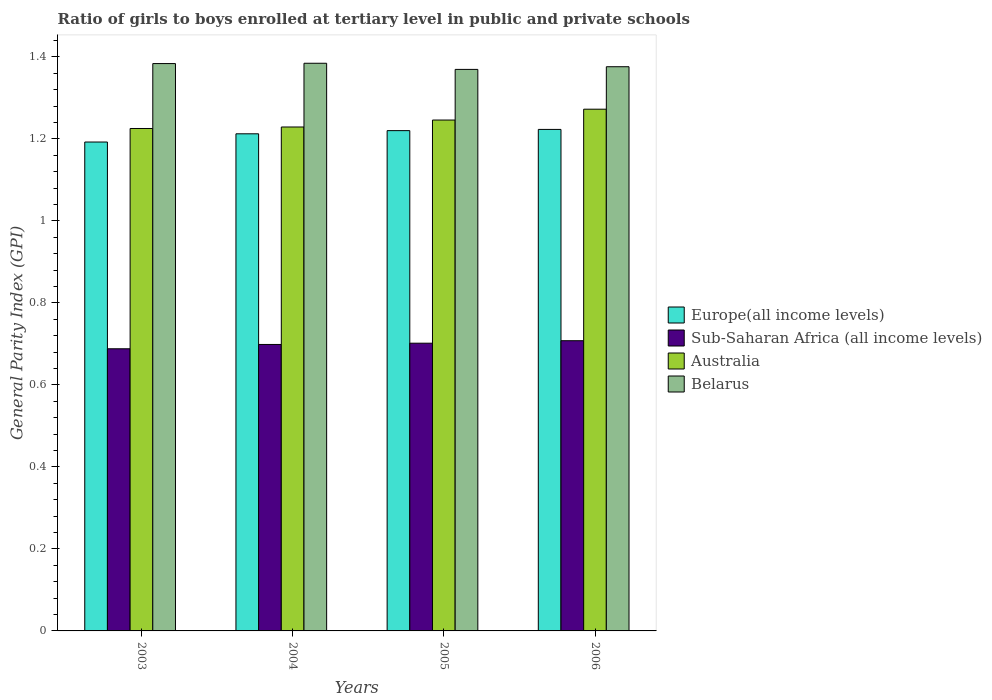Are the number of bars per tick equal to the number of legend labels?
Your answer should be very brief. Yes. How many bars are there on the 4th tick from the right?
Provide a succinct answer. 4. What is the label of the 1st group of bars from the left?
Offer a very short reply. 2003. What is the general parity index in Europe(all income levels) in 2003?
Ensure brevity in your answer.  1.19. Across all years, what is the maximum general parity index in Sub-Saharan Africa (all income levels)?
Keep it short and to the point. 0.71. Across all years, what is the minimum general parity index in Europe(all income levels)?
Your answer should be very brief. 1.19. In which year was the general parity index in Europe(all income levels) maximum?
Give a very brief answer. 2006. In which year was the general parity index in Sub-Saharan Africa (all income levels) minimum?
Your response must be concise. 2003. What is the total general parity index in Belarus in the graph?
Your answer should be compact. 5.51. What is the difference between the general parity index in Sub-Saharan Africa (all income levels) in 2004 and that in 2006?
Keep it short and to the point. -0.01. What is the difference between the general parity index in Europe(all income levels) in 2005 and the general parity index in Sub-Saharan Africa (all income levels) in 2006?
Offer a terse response. 0.51. What is the average general parity index in Belarus per year?
Provide a succinct answer. 1.38. In the year 2004, what is the difference between the general parity index in Australia and general parity index in Sub-Saharan Africa (all income levels)?
Offer a very short reply. 0.53. In how many years, is the general parity index in Belarus greater than 0.16?
Make the answer very short. 4. What is the ratio of the general parity index in Australia in 2004 to that in 2006?
Keep it short and to the point. 0.97. Is the difference between the general parity index in Australia in 2003 and 2004 greater than the difference between the general parity index in Sub-Saharan Africa (all income levels) in 2003 and 2004?
Ensure brevity in your answer.  Yes. What is the difference between the highest and the second highest general parity index in Belarus?
Your response must be concise. 0. What is the difference between the highest and the lowest general parity index in Sub-Saharan Africa (all income levels)?
Offer a terse response. 0.02. In how many years, is the general parity index in Australia greater than the average general parity index in Australia taken over all years?
Offer a terse response. 2. Is the sum of the general parity index in Europe(all income levels) in 2003 and 2006 greater than the maximum general parity index in Belarus across all years?
Ensure brevity in your answer.  Yes. Is it the case that in every year, the sum of the general parity index in Sub-Saharan Africa (all income levels) and general parity index in Australia is greater than the sum of general parity index in Belarus and general parity index in Europe(all income levels)?
Your answer should be compact. Yes. What does the 2nd bar from the left in 2005 represents?
Offer a terse response. Sub-Saharan Africa (all income levels). What does the 3rd bar from the right in 2006 represents?
Provide a short and direct response. Sub-Saharan Africa (all income levels). How many years are there in the graph?
Your answer should be very brief. 4. What is the difference between two consecutive major ticks on the Y-axis?
Your answer should be very brief. 0.2. Are the values on the major ticks of Y-axis written in scientific E-notation?
Give a very brief answer. No. Does the graph contain any zero values?
Keep it short and to the point. No. Where does the legend appear in the graph?
Your response must be concise. Center right. What is the title of the graph?
Provide a succinct answer. Ratio of girls to boys enrolled at tertiary level in public and private schools. What is the label or title of the X-axis?
Your answer should be very brief. Years. What is the label or title of the Y-axis?
Keep it short and to the point. General Parity Index (GPI). What is the General Parity Index (GPI) in Europe(all income levels) in 2003?
Make the answer very short. 1.19. What is the General Parity Index (GPI) in Sub-Saharan Africa (all income levels) in 2003?
Your response must be concise. 0.69. What is the General Parity Index (GPI) in Australia in 2003?
Offer a terse response. 1.23. What is the General Parity Index (GPI) of Belarus in 2003?
Your answer should be very brief. 1.38. What is the General Parity Index (GPI) of Europe(all income levels) in 2004?
Ensure brevity in your answer.  1.21. What is the General Parity Index (GPI) in Sub-Saharan Africa (all income levels) in 2004?
Make the answer very short. 0.7. What is the General Parity Index (GPI) of Australia in 2004?
Provide a succinct answer. 1.23. What is the General Parity Index (GPI) of Belarus in 2004?
Your answer should be very brief. 1.38. What is the General Parity Index (GPI) in Europe(all income levels) in 2005?
Offer a very short reply. 1.22. What is the General Parity Index (GPI) in Sub-Saharan Africa (all income levels) in 2005?
Give a very brief answer. 0.7. What is the General Parity Index (GPI) in Australia in 2005?
Keep it short and to the point. 1.25. What is the General Parity Index (GPI) in Belarus in 2005?
Offer a very short reply. 1.37. What is the General Parity Index (GPI) in Europe(all income levels) in 2006?
Provide a succinct answer. 1.22. What is the General Parity Index (GPI) in Sub-Saharan Africa (all income levels) in 2006?
Offer a terse response. 0.71. What is the General Parity Index (GPI) of Australia in 2006?
Keep it short and to the point. 1.27. What is the General Parity Index (GPI) in Belarus in 2006?
Ensure brevity in your answer.  1.38. Across all years, what is the maximum General Parity Index (GPI) of Europe(all income levels)?
Provide a short and direct response. 1.22. Across all years, what is the maximum General Parity Index (GPI) of Sub-Saharan Africa (all income levels)?
Provide a short and direct response. 0.71. Across all years, what is the maximum General Parity Index (GPI) of Australia?
Offer a terse response. 1.27. Across all years, what is the maximum General Parity Index (GPI) in Belarus?
Your answer should be very brief. 1.38. Across all years, what is the minimum General Parity Index (GPI) of Europe(all income levels)?
Make the answer very short. 1.19. Across all years, what is the minimum General Parity Index (GPI) of Sub-Saharan Africa (all income levels)?
Your response must be concise. 0.69. Across all years, what is the minimum General Parity Index (GPI) of Australia?
Your answer should be very brief. 1.23. Across all years, what is the minimum General Parity Index (GPI) in Belarus?
Offer a terse response. 1.37. What is the total General Parity Index (GPI) of Europe(all income levels) in the graph?
Keep it short and to the point. 4.85. What is the total General Parity Index (GPI) of Sub-Saharan Africa (all income levels) in the graph?
Offer a terse response. 2.8. What is the total General Parity Index (GPI) in Australia in the graph?
Your answer should be very brief. 4.97. What is the total General Parity Index (GPI) of Belarus in the graph?
Offer a terse response. 5.51. What is the difference between the General Parity Index (GPI) of Europe(all income levels) in 2003 and that in 2004?
Provide a succinct answer. -0.02. What is the difference between the General Parity Index (GPI) in Sub-Saharan Africa (all income levels) in 2003 and that in 2004?
Ensure brevity in your answer.  -0.01. What is the difference between the General Parity Index (GPI) in Australia in 2003 and that in 2004?
Provide a short and direct response. -0. What is the difference between the General Parity Index (GPI) in Belarus in 2003 and that in 2004?
Provide a short and direct response. -0. What is the difference between the General Parity Index (GPI) of Europe(all income levels) in 2003 and that in 2005?
Ensure brevity in your answer.  -0.03. What is the difference between the General Parity Index (GPI) of Sub-Saharan Africa (all income levels) in 2003 and that in 2005?
Make the answer very short. -0.01. What is the difference between the General Parity Index (GPI) of Australia in 2003 and that in 2005?
Your response must be concise. -0.02. What is the difference between the General Parity Index (GPI) in Belarus in 2003 and that in 2005?
Offer a terse response. 0.01. What is the difference between the General Parity Index (GPI) of Europe(all income levels) in 2003 and that in 2006?
Offer a very short reply. -0.03. What is the difference between the General Parity Index (GPI) of Sub-Saharan Africa (all income levels) in 2003 and that in 2006?
Keep it short and to the point. -0.02. What is the difference between the General Parity Index (GPI) of Australia in 2003 and that in 2006?
Ensure brevity in your answer.  -0.05. What is the difference between the General Parity Index (GPI) in Belarus in 2003 and that in 2006?
Your response must be concise. 0.01. What is the difference between the General Parity Index (GPI) in Europe(all income levels) in 2004 and that in 2005?
Offer a very short reply. -0.01. What is the difference between the General Parity Index (GPI) of Sub-Saharan Africa (all income levels) in 2004 and that in 2005?
Provide a succinct answer. -0. What is the difference between the General Parity Index (GPI) of Australia in 2004 and that in 2005?
Ensure brevity in your answer.  -0.02. What is the difference between the General Parity Index (GPI) in Belarus in 2004 and that in 2005?
Offer a very short reply. 0.01. What is the difference between the General Parity Index (GPI) of Europe(all income levels) in 2004 and that in 2006?
Offer a terse response. -0.01. What is the difference between the General Parity Index (GPI) in Sub-Saharan Africa (all income levels) in 2004 and that in 2006?
Make the answer very short. -0.01. What is the difference between the General Parity Index (GPI) of Australia in 2004 and that in 2006?
Your answer should be compact. -0.04. What is the difference between the General Parity Index (GPI) of Belarus in 2004 and that in 2006?
Your answer should be compact. 0.01. What is the difference between the General Parity Index (GPI) of Europe(all income levels) in 2005 and that in 2006?
Provide a short and direct response. -0. What is the difference between the General Parity Index (GPI) of Sub-Saharan Africa (all income levels) in 2005 and that in 2006?
Provide a short and direct response. -0.01. What is the difference between the General Parity Index (GPI) in Australia in 2005 and that in 2006?
Your answer should be very brief. -0.03. What is the difference between the General Parity Index (GPI) in Belarus in 2005 and that in 2006?
Keep it short and to the point. -0.01. What is the difference between the General Parity Index (GPI) in Europe(all income levels) in 2003 and the General Parity Index (GPI) in Sub-Saharan Africa (all income levels) in 2004?
Keep it short and to the point. 0.49. What is the difference between the General Parity Index (GPI) of Europe(all income levels) in 2003 and the General Parity Index (GPI) of Australia in 2004?
Keep it short and to the point. -0.04. What is the difference between the General Parity Index (GPI) of Europe(all income levels) in 2003 and the General Parity Index (GPI) of Belarus in 2004?
Provide a short and direct response. -0.19. What is the difference between the General Parity Index (GPI) of Sub-Saharan Africa (all income levels) in 2003 and the General Parity Index (GPI) of Australia in 2004?
Your answer should be compact. -0.54. What is the difference between the General Parity Index (GPI) in Sub-Saharan Africa (all income levels) in 2003 and the General Parity Index (GPI) in Belarus in 2004?
Keep it short and to the point. -0.7. What is the difference between the General Parity Index (GPI) in Australia in 2003 and the General Parity Index (GPI) in Belarus in 2004?
Make the answer very short. -0.16. What is the difference between the General Parity Index (GPI) in Europe(all income levels) in 2003 and the General Parity Index (GPI) in Sub-Saharan Africa (all income levels) in 2005?
Your answer should be very brief. 0.49. What is the difference between the General Parity Index (GPI) in Europe(all income levels) in 2003 and the General Parity Index (GPI) in Australia in 2005?
Your answer should be very brief. -0.05. What is the difference between the General Parity Index (GPI) in Europe(all income levels) in 2003 and the General Parity Index (GPI) in Belarus in 2005?
Offer a terse response. -0.18. What is the difference between the General Parity Index (GPI) of Sub-Saharan Africa (all income levels) in 2003 and the General Parity Index (GPI) of Australia in 2005?
Keep it short and to the point. -0.56. What is the difference between the General Parity Index (GPI) of Sub-Saharan Africa (all income levels) in 2003 and the General Parity Index (GPI) of Belarus in 2005?
Your response must be concise. -0.68. What is the difference between the General Parity Index (GPI) of Australia in 2003 and the General Parity Index (GPI) of Belarus in 2005?
Your answer should be very brief. -0.14. What is the difference between the General Parity Index (GPI) in Europe(all income levels) in 2003 and the General Parity Index (GPI) in Sub-Saharan Africa (all income levels) in 2006?
Make the answer very short. 0.48. What is the difference between the General Parity Index (GPI) of Europe(all income levels) in 2003 and the General Parity Index (GPI) of Australia in 2006?
Offer a terse response. -0.08. What is the difference between the General Parity Index (GPI) of Europe(all income levels) in 2003 and the General Parity Index (GPI) of Belarus in 2006?
Your response must be concise. -0.18. What is the difference between the General Parity Index (GPI) of Sub-Saharan Africa (all income levels) in 2003 and the General Parity Index (GPI) of Australia in 2006?
Provide a short and direct response. -0.58. What is the difference between the General Parity Index (GPI) of Sub-Saharan Africa (all income levels) in 2003 and the General Parity Index (GPI) of Belarus in 2006?
Offer a very short reply. -0.69. What is the difference between the General Parity Index (GPI) in Australia in 2003 and the General Parity Index (GPI) in Belarus in 2006?
Your answer should be very brief. -0.15. What is the difference between the General Parity Index (GPI) of Europe(all income levels) in 2004 and the General Parity Index (GPI) of Sub-Saharan Africa (all income levels) in 2005?
Provide a short and direct response. 0.51. What is the difference between the General Parity Index (GPI) in Europe(all income levels) in 2004 and the General Parity Index (GPI) in Australia in 2005?
Provide a short and direct response. -0.03. What is the difference between the General Parity Index (GPI) of Europe(all income levels) in 2004 and the General Parity Index (GPI) of Belarus in 2005?
Provide a succinct answer. -0.16. What is the difference between the General Parity Index (GPI) of Sub-Saharan Africa (all income levels) in 2004 and the General Parity Index (GPI) of Australia in 2005?
Offer a terse response. -0.55. What is the difference between the General Parity Index (GPI) in Sub-Saharan Africa (all income levels) in 2004 and the General Parity Index (GPI) in Belarus in 2005?
Offer a terse response. -0.67. What is the difference between the General Parity Index (GPI) in Australia in 2004 and the General Parity Index (GPI) in Belarus in 2005?
Keep it short and to the point. -0.14. What is the difference between the General Parity Index (GPI) of Europe(all income levels) in 2004 and the General Parity Index (GPI) of Sub-Saharan Africa (all income levels) in 2006?
Offer a very short reply. 0.5. What is the difference between the General Parity Index (GPI) in Europe(all income levels) in 2004 and the General Parity Index (GPI) in Australia in 2006?
Provide a short and direct response. -0.06. What is the difference between the General Parity Index (GPI) in Europe(all income levels) in 2004 and the General Parity Index (GPI) in Belarus in 2006?
Your answer should be very brief. -0.16. What is the difference between the General Parity Index (GPI) of Sub-Saharan Africa (all income levels) in 2004 and the General Parity Index (GPI) of Australia in 2006?
Offer a very short reply. -0.57. What is the difference between the General Parity Index (GPI) in Sub-Saharan Africa (all income levels) in 2004 and the General Parity Index (GPI) in Belarus in 2006?
Offer a terse response. -0.68. What is the difference between the General Parity Index (GPI) in Australia in 2004 and the General Parity Index (GPI) in Belarus in 2006?
Make the answer very short. -0.15. What is the difference between the General Parity Index (GPI) of Europe(all income levels) in 2005 and the General Parity Index (GPI) of Sub-Saharan Africa (all income levels) in 2006?
Offer a very short reply. 0.51. What is the difference between the General Parity Index (GPI) in Europe(all income levels) in 2005 and the General Parity Index (GPI) in Australia in 2006?
Offer a terse response. -0.05. What is the difference between the General Parity Index (GPI) of Europe(all income levels) in 2005 and the General Parity Index (GPI) of Belarus in 2006?
Offer a very short reply. -0.16. What is the difference between the General Parity Index (GPI) in Sub-Saharan Africa (all income levels) in 2005 and the General Parity Index (GPI) in Australia in 2006?
Your response must be concise. -0.57. What is the difference between the General Parity Index (GPI) of Sub-Saharan Africa (all income levels) in 2005 and the General Parity Index (GPI) of Belarus in 2006?
Your response must be concise. -0.67. What is the difference between the General Parity Index (GPI) in Australia in 2005 and the General Parity Index (GPI) in Belarus in 2006?
Your response must be concise. -0.13. What is the average General Parity Index (GPI) of Europe(all income levels) per year?
Provide a short and direct response. 1.21. What is the average General Parity Index (GPI) in Sub-Saharan Africa (all income levels) per year?
Keep it short and to the point. 0.7. What is the average General Parity Index (GPI) in Australia per year?
Give a very brief answer. 1.24. What is the average General Parity Index (GPI) of Belarus per year?
Your answer should be compact. 1.38. In the year 2003, what is the difference between the General Parity Index (GPI) of Europe(all income levels) and General Parity Index (GPI) of Sub-Saharan Africa (all income levels)?
Make the answer very short. 0.5. In the year 2003, what is the difference between the General Parity Index (GPI) in Europe(all income levels) and General Parity Index (GPI) in Australia?
Your response must be concise. -0.03. In the year 2003, what is the difference between the General Parity Index (GPI) in Europe(all income levels) and General Parity Index (GPI) in Belarus?
Ensure brevity in your answer.  -0.19. In the year 2003, what is the difference between the General Parity Index (GPI) in Sub-Saharan Africa (all income levels) and General Parity Index (GPI) in Australia?
Offer a terse response. -0.54. In the year 2003, what is the difference between the General Parity Index (GPI) of Sub-Saharan Africa (all income levels) and General Parity Index (GPI) of Belarus?
Provide a short and direct response. -0.7. In the year 2003, what is the difference between the General Parity Index (GPI) in Australia and General Parity Index (GPI) in Belarus?
Give a very brief answer. -0.16. In the year 2004, what is the difference between the General Parity Index (GPI) of Europe(all income levels) and General Parity Index (GPI) of Sub-Saharan Africa (all income levels)?
Give a very brief answer. 0.51. In the year 2004, what is the difference between the General Parity Index (GPI) in Europe(all income levels) and General Parity Index (GPI) in Australia?
Ensure brevity in your answer.  -0.02. In the year 2004, what is the difference between the General Parity Index (GPI) in Europe(all income levels) and General Parity Index (GPI) in Belarus?
Your answer should be compact. -0.17. In the year 2004, what is the difference between the General Parity Index (GPI) in Sub-Saharan Africa (all income levels) and General Parity Index (GPI) in Australia?
Make the answer very short. -0.53. In the year 2004, what is the difference between the General Parity Index (GPI) of Sub-Saharan Africa (all income levels) and General Parity Index (GPI) of Belarus?
Ensure brevity in your answer.  -0.69. In the year 2004, what is the difference between the General Parity Index (GPI) of Australia and General Parity Index (GPI) of Belarus?
Provide a succinct answer. -0.16. In the year 2005, what is the difference between the General Parity Index (GPI) of Europe(all income levels) and General Parity Index (GPI) of Sub-Saharan Africa (all income levels)?
Provide a short and direct response. 0.52. In the year 2005, what is the difference between the General Parity Index (GPI) of Europe(all income levels) and General Parity Index (GPI) of Australia?
Ensure brevity in your answer.  -0.03. In the year 2005, what is the difference between the General Parity Index (GPI) in Europe(all income levels) and General Parity Index (GPI) in Belarus?
Your answer should be very brief. -0.15. In the year 2005, what is the difference between the General Parity Index (GPI) of Sub-Saharan Africa (all income levels) and General Parity Index (GPI) of Australia?
Your answer should be very brief. -0.54. In the year 2005, what is the difference between the General Parity Index (GPI) of Sub-Saharan Africa (all income levels) and General Parity Index (GPI) of Belarus?
Give a very brief answer. -0.67. In the year 2005, what is the difference between the General Parity Index (GPI) of Australia and General Parity Index (GPI) of Belarus?
Provide a succinct answer. -0.12. In the year 2006, what is the difference between the General Parity Index (GPI) of Europe(all income levels) and General Parity Index (GPI) of Sub-Saharan Africa (all income levels)?
Offer a very short reply. 0.52. In the year 2006, what is the difference between the General Parity Index (GPI) in Europe(all income levels) and General Parity Index (GPI) in Australia?
Offer a terse response. -0.05. In the year 2006, what is the difference between the General Parity Index (GPI) in Europe(all income levels) and General Parity Index (GPI) in Belarus?
Offer a very short reply. -0.15. In the year 2006, what is the difference between the General Parity Index (GPI) in Sub-Saharan Africa (all income levels) and General Parity Index (GPI) in Australia?
Provide a short and direct response. -0.56. In the year 2006, what is the difference between the General Parity Index (GPI) in Sub-Saharan Africa (all income levels) and General Parity Index (GPI) in Belarus?
Your response must be concise. -0.67. In the year 2006, what is the difference between the General Parity Index (GPI) of Australia and General Parity Index (GPI) of Belarus?
Keep it short and to the point. -0.1. What is the ratio of the General Parity Index (GPI) of Europe(all income levels) in 2003 to that in 2004?
Offer a very short reply. 0.98. What is the ratio of the General Parity Index (GPI) in Sub-Saharan Africa (all income levels) in 2003 to that in 2004?
Ensure brevity in your answer.  0.98. What is the ratio of the General Parity Index (GPI) in Europe(all income levels) in 2003 to that in 2005?
Your response must be concise. 0.98. What is the ratio of the General Parity Index (GPI) of Sub-Saharan Africa (all income levels) in 2003 to that in 2005?
Make the answer very short. 0.98. What is the ratio of the General Parity Index (GPI) in Australia in 2003 to that in 2005?
Your answer should be compact. 0.98. What is the ratio of the General Parity Index (GPI) in Belarus in 2003 to that in 2005?
Give a very brief answer. 1.01. What is the ratio of the General Parity Index (GPI) in Europe(all income levels) in 2003 to that in 2006?
Your response must be concise. 0.97. What is the ratio of the General Parity Index (GPI) in Sub-Saharan Africa (all income levels) in 2003 to that in 2006?
Your answer should be compact. 0.97. What is the ratio of the General Parity Index (GPI) of Australia in 2003 to that in 2006?
Ensure brevity in your answer.  0.96. What is the ratio of the General Parity Index (GPI) in Belarus in 2003 to that in 2006?
Provide a short and direct response. 1.01. What is the ratio of the General Parity Index (GPI) of Europe(all income levels) in 2004 to that in 2005?
Make the answer very short. 0.99. What is the ratio of the General Parity Index (GPI) of Sub-Saharan Africa (all income levels) in 2004 to that in 2005?
Make the answer very short. 1. What is the ratio of the General Parity Index (GPI) of Australia in 2004 to that in 2005?
Give a very brief answer. 0.99. What is the ratio of the General Parity Index (GPI) in Belarus in 2004 to that in 2005?
Ensure brevity in your answer.  1.01. What is the ratio of the General Parity Index (GPI) of Europe(all income levels) in 2004 to that in 2006?
Provide a short and direct response. 0.99. What is the ratio of the General Parity Index (GPI) in Sub-Saharan Africa (all income levels) in 2004 to that in 2006?
Your answer should be very brief. 0.99. What is the ratio of the General Parity Index (GPI) of Australia in 2004 to that in 2006?
Keep it short and to the point. 0.97. What is the ratio of the General Parity Index (GPI) in Australia in 2005 to that in 2006?
Provide a short and direct response. 0.98. What is the ratio of the General Parity Index (GPI) in Belarus in 2005 to that in 2006?
Give a very brief answer. 1. What is the difference between the highest and the second highest General Parity Index (GPI) in Europe(all income levels)?
Give a very brief answer. 0. What is the difference between the highest and the second highest General Parity Index (GPI) of Sub-Saharan Africa (all income levels)?
Keep it short and to the point. 0.01. What is the difference between the highest and the second highest General Parity Index (GPI) of Australia?
Offer a very short reply. 0.03. What is the difference between the highest and the second highest General Parity Index (GPI) of Belarus?
Your response must be concise. 0. What is the difference between the highest and the lowest General Parity Index (GPI) of Europe(all income levels)?
Give a very brief answer. 0.03. What is the difference between the highest and the lowest General Parity Index (GPI) in Sub-Saharan Africa (all income levels)?
Your response must be concise. 0.02. What is the difference between the highest and the lowest General Parity Index (GPI) of Australia?
Your answer should be very brief. 0.05. What is the difference between the highest and the lowest General Parity Index (GPI) of Belarus?
Ensure brevity in your answer.  0.01. 